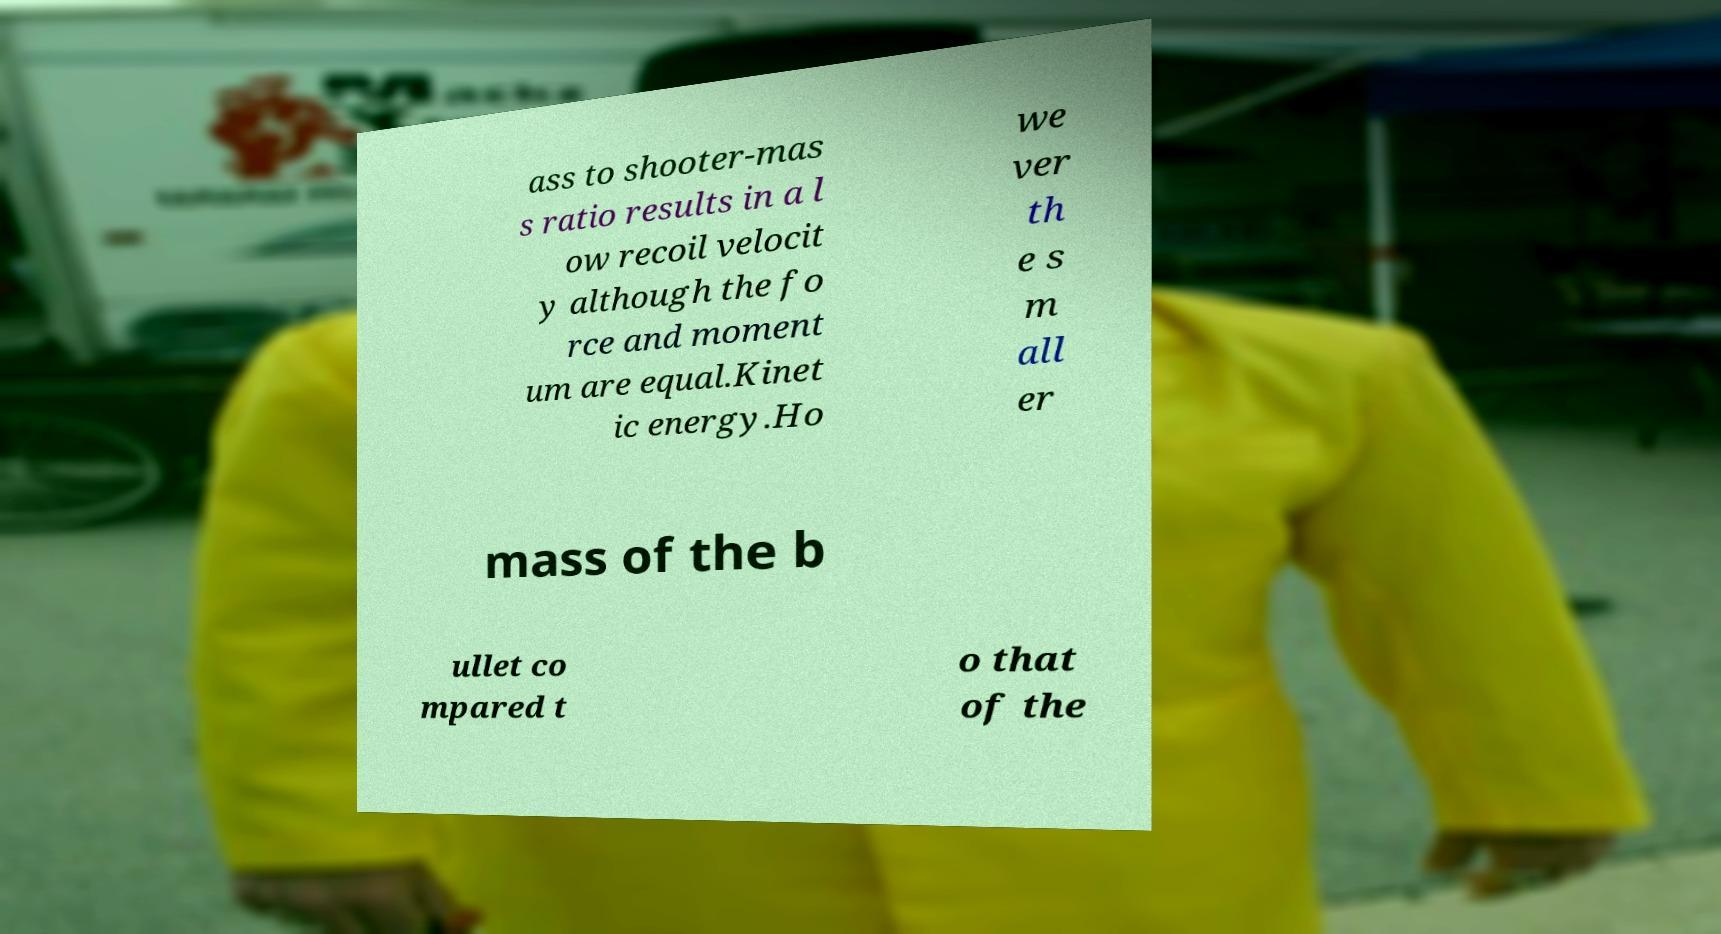For documentation purposes, I need the text within this image transcribed. Could you provide that? ass to shooter-mas s ratio results in a l ow recoil velocit y although the fo rce and moment um are equal.Kinet ic energy.Ho we ver th e s m all er mass of the b ullet co mpared t o that of the 